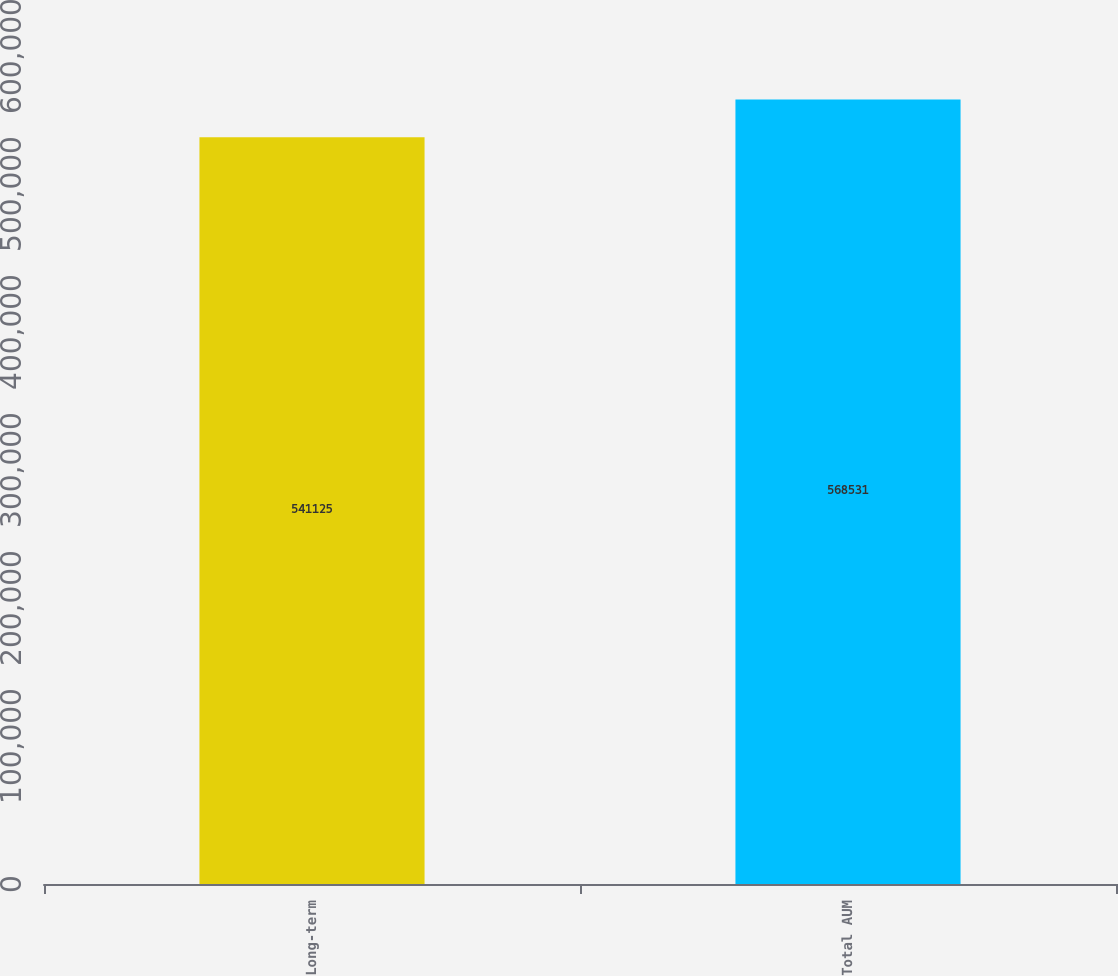Convert chart to OTSL. <chart><loc_0><loc_0><loc_500><loc_500><bar_chart><fcel>Long-term<fcel>Total AUM<nl><fcel>541125<fcel>568531<nl></chart> 